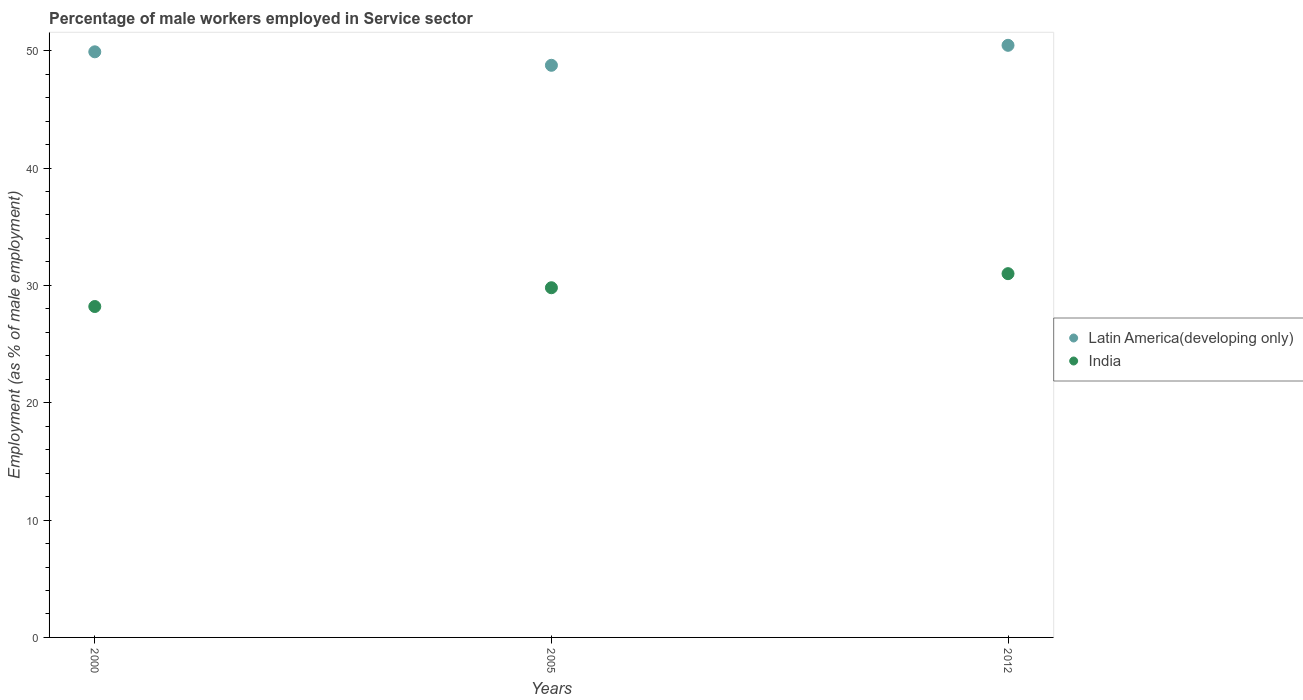Is the number of dotlines equal to the number of legend labels?
Your response must be concise. Yes. What is the percentage of male workers employed in Service sector in India in 2005?
Keep it short and to the point. 29.8. Across all years, what is the minimum percentage of male workers employed in Service sector in Latin America(developing only)?
Provide a succinct answer. 48.76. What is the total percentage of male workers employed in Service sector in India in the graph?
Make the answer very short. 89. What is the difference between the percentage of male workers employed in Service sector in Latin America(developing only) in 2005 and that in 2012?
Your response must be concise. -1.7. What is the difference between the percentage of male workers employed in Service sector in India in 2005 and the percentage of male workers employed in Service sector in Latin America(developing only) in 2000?
Your answer should be compact. -20.11. What is the average percentage of male workers employed in Service sector in Latin America(developing only) per year?
Give a very brief answer. 49.71. In the year 2000, what is the difference between the percentage of male workers employed in Service sector in India and percentage of male workers employed in Service sector in Latin America(developing only)?
Ensure brevity in your answer.  -21.71. In how many years, is the percentage of male workers employed in Service sector in India greater than 28 %?
Your response must be concise. 3. What is the ratio of the percentage of male workers employed in Service sector in Latin America(developing only) in 2000 to that in 2012?
Make the answer very short. 0.99. Is the percentage of male workers employed in Service sector in Latin America(developing only) in 2005 less than that in 2012?
Offer a terse response. Yes. What is the difference between the highest and the second highest percentage of male workers employed in Service sector in Latin America(developing only)?
Provide a succinct answer. 0.55. What is the difference between the highest and the lowest percentage of male workers employed in Service sector in India?
Offer a terse response. 2.8. Is the sum of the percentage of male workers employed in Service sector in Latin America(developing only) in 2000 and 2005 greater than the maximum percentage of male workers employed in Service sector in India across all years?
Provide a succinct answer. Yes. Does the percentage of male workers employed in Service sector in Latin America(developing only) monotonically increase over the years?
Make the answer very short. No. Is the percentage of male workers employed in Service sector in India strictly less than the percentage of male workers employed in Service sector in Latin America(developing only) over the years?
Your response must be concise. Yes. How many dotlines are there?
Provide a succinct answer. 2. Are the values on the major ticks of Y-axis written in scientific E-notation?
Make the answer very short. No. Does the graph contain any zero values?
Provide a succinct answer. No. How are the legend labels stacked?
Make the answer very short. Vertical. What is the title of the graph?
Keep it short and to the point. Percentage of male workers employed in Service sector. What is the label or title of the X-axis?
Offer a terse response. Years. What is the label or title of the Y-axis?
Make the answer very short. Employment (as % of male employment). What is the Employment (as % of male employment) of Latin America(developing only) in 2000?
Your answer should be compact. 49.91. What is the Employment (as % of male employment) of India in 2000?
Make the answer very short. 28.2. What is the Employment (as % of male employment) of Latin America(developing only) in 2005?
Keep it short and to the point. 48.76. What is the Employment (as % of male employment) of India in 2005?
Your answer should be compact. 29.8. What is the Employment (as % of male employment) of Latin America(developing only) in 2012?
Your response must be concise. 50.46. Across all years, what is the maximum Employment (as % of male employment) in Latin America(developing only)?
Your answer should be very brief. 50.46. Across all years, what is the maximum Employment (as % of male employment) in India?
Ensure brevity in your answer.  31. Across all years, what is the minimum Employment (as % of male employment) in Latin America(developing only)?
Keep it short and to the point. 48.76. Across all years, what is the minimum Employment (as % of male employment) of India?
Ensure brevity in your answer.  28.2. What is the total Employment (as % of male employment) in Latin America(developing only) in the graph?
Your answer should be very brief. 149.12. What is the total Employment (as % of male employment) in India in the graph?
Your answer should be very brief. 89. What is the difference between the Employment (as % of male employment) of Latin America(developing only) in 2000 and that in 2005?
Your response must be concise. 1.15. What is the difference between the Employment (as % of male employment) of India in 2000 and that in 2005?
Offer a very short reply. -1.6. What is the difference between the Employment (as % of male employment) in Latin America(developing only) in 2000 and that in 2012?
Provide a short and direct response. -0.55. What is the difference between the Employment (as % of male employment) of India in 2000 and that in 2012?
Keep it short and to the point. -2.8. What is the difference between the Employment (as % of male employment) of Latin America(developing only) in 2005 and that in 2012?
Provide a succinct answer. -1.7. What is the difference between the Employment (as % of male employment) of Latin America(developing only) in 2000 and the Employment (as % of male employment) of India in 2005?
Make the answer very short. 20.11. What is the difference between the Employment (as % of male employment) of Latin America(developing only) in 2000 and the Employment (as % of male employment) of India in 2012?
Ensure brevity in your answer.  18.91. What is the difference between the Employment (as % of male employment) of Latin America(developing only) in 2005 and the Employment (as % of male employment) of India in 2012?
Offer a very short reply. 17.76. What is the average Employment (as % of male employment) in Latin America(developing only) per year?
Offer a terse response. 49.71. What is the average Employment (as % of male employment) of India per year?
Ensure brevity in your answer.  29.67. In the year 2000, what is the difference between the Employment (as % of male employment) in Latin America(developing only) and Employment (as % of male employment) in India?
Provide a short and direct response. 21.71. In the year 2005, what is the difference between the Employment (as % of male employment) in Latin America(developing only) and Employment (as % of male employment) in India?
Your answer should be compact. 18.96. In the year 2012, what is the difference between the Employment (as % of male employment) of Latin America(developing only) and Employment (as % of male employment) of India?
Your answer should be compact. 19.46. What is the ratio of the Employment (as % of male employment) in Latin America(developing only) in 2000 to that in 2005?
Make the answer very short. 1.02. What is the ratio of the Employment (as % of male employment) in India in 2000 to that in 2005?
Your answer should be compact. 0.95. What is the ratio of the Employment (as % of male employment) in Latin America(developing only) in 2000 to that in 2012?
Provide a succinct answer. 0.99. What is the ratio of the Employment (as % of male employment) of India in 2000 to that in 2012?
Provide a short and direct response. 0.91. What is the ratio of the Employment (as % of male employment) of Latin America(developing only) in 2005 to that in 2012?
Offer a terse response. 0.97. What is the ratio of the Employment (as % of male employment) of India in 2005 to that in 2012?
Keep it short and to the point. 0.96. What is the difference between the highest and the second highest Employment (as % of male employment) of Latin America(developing only)?
Give a very brief answer. 0.55. What is the difference between the highest and the lowest Employment (as % of male employment) in Latin America(developing only)?
Your answer should be very brief. 1.7. What is the difference between the highest and the lowest Employment (as % of male employment) of India?
Your answer should be compact. 2.8. 